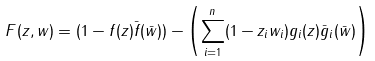Convert formula to latex. <formula><loc_0><loc_0><loc_500><loc_500>F ( z , w ) = ( 1 - f ( z ) \bar { f } ( \bar { w } ) ) - \left ( \sum _ { i = 1 } ^ { n } ( 1 - z _ { i } w _ { i } ) g _ { i } ( z ) \bar { g } _ { i } ( \bar { w } ) \right )</formula> 